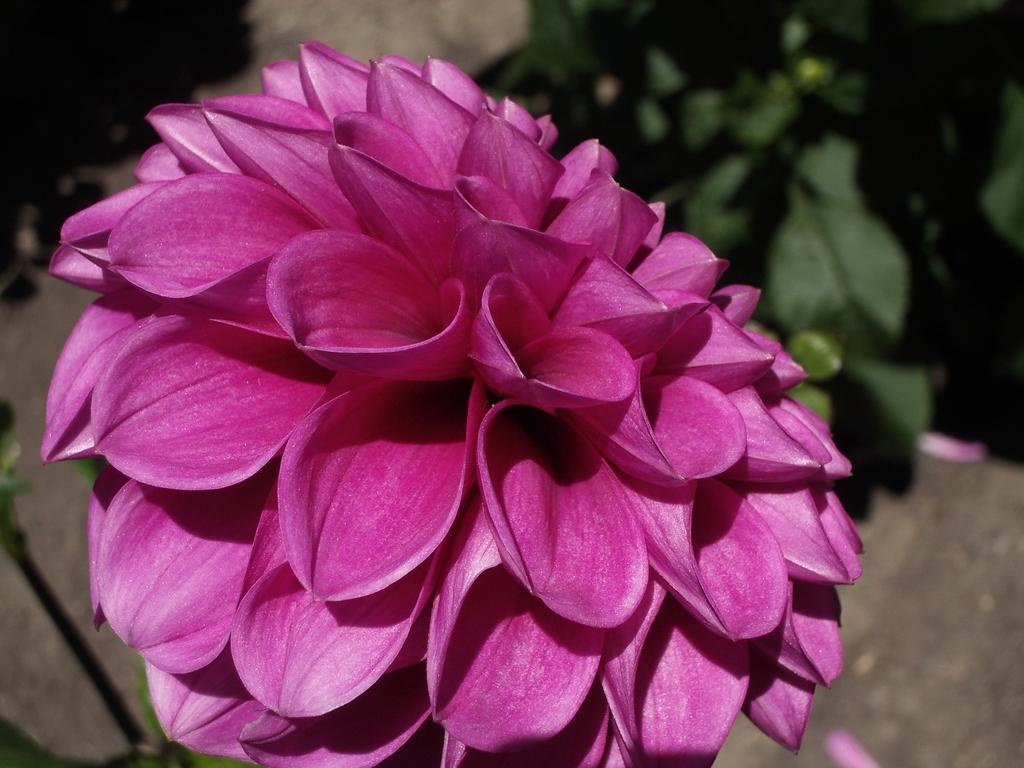What is the main subject of the image? There is a flower in the image. Can you describe the background of the image? There are plants visible in the background of the image. What type of pie is being served on the wall in the image? There is no pie or wall present in the image; it only features a flower and plants in the background. 